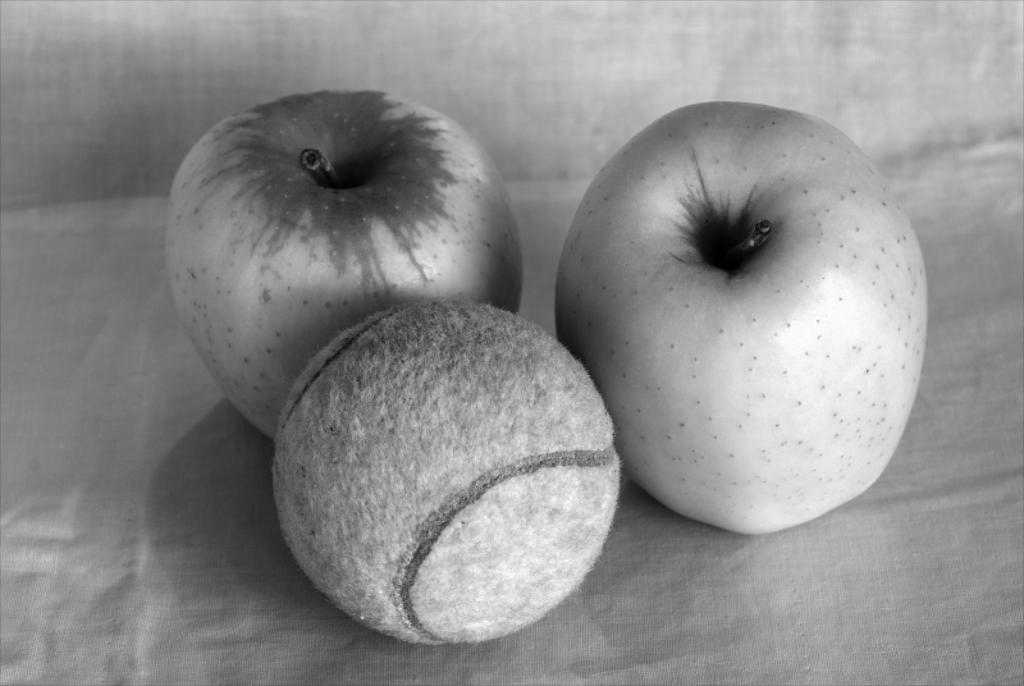What is the main object in the image? There is a ball in the image. What other items can be seen in the image? There are fruits in the image. Where are the ball and fruits placed? The ball and fruits are placed on a surface. What is the color scheme of the image? The image is in black and white color. What type of health advice can be seen in the image? There is no health advice present in the image; it features a ball and fruits on a surface in black and white. What type of glass object is visible in the image? There is no glass object present in the image. 